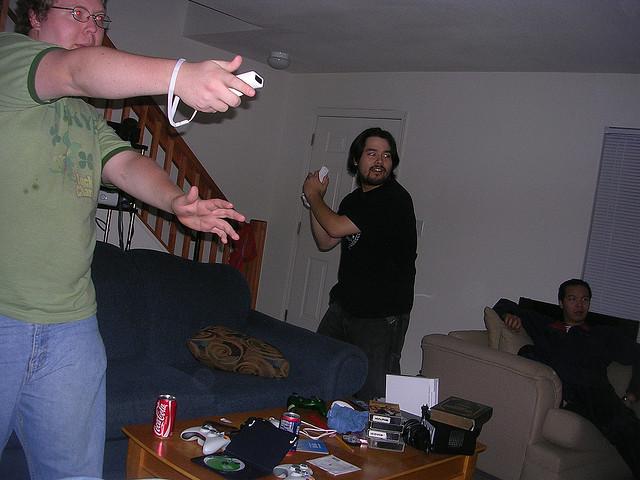How many people?
Be succinct. 3. What game are they playing?
Concise answer only. Wii. What is scattered all over the floor?
Answer briefly. Trash. Does this house have stairs?
Quick response, please. Yes. 